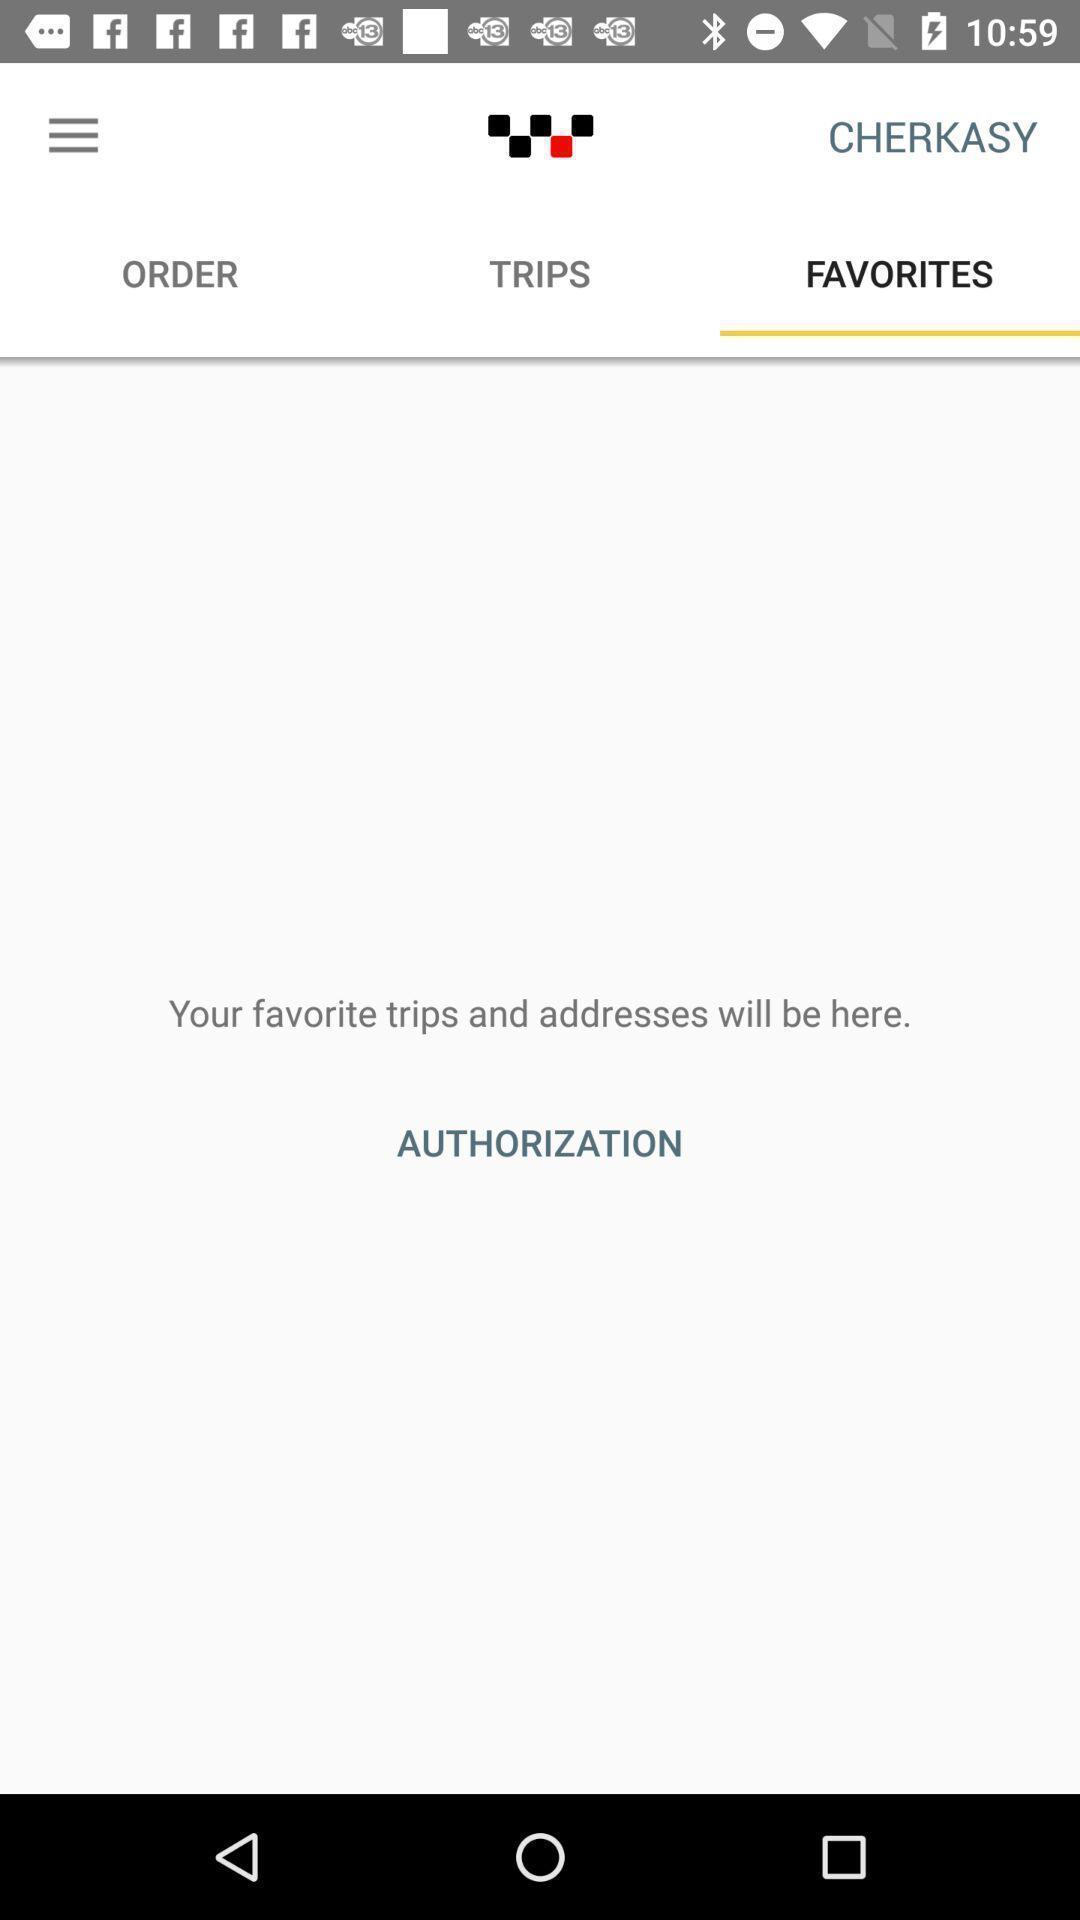Summarize the information in this screenshot. Page with your favorite trips will be here in application. 